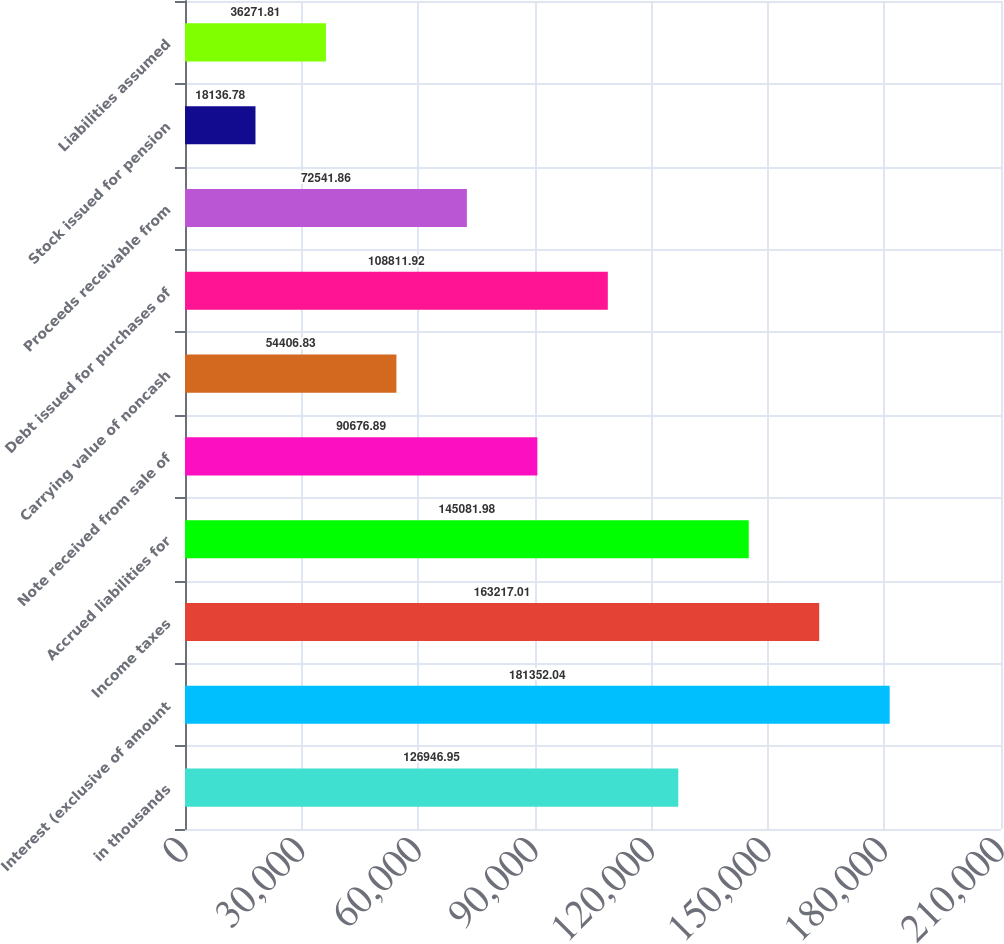Convert chart. <chart><loc_0><loc_0><loc_500><loc_500><bar_chart><fcel>in thousands<fcel>Interest (exclusive of amount<fcel>Income taxes<fcel>Accrued liabilities for<fcel>Note received from sale of<fcel>Carrying value of noncash<fcel>Debt issued for purchases of<fcel>Proceeds receivable from<fcel>Stock issued for pension<fcel>Liabilities assumed<nl><fcel>126947<fcel>181352<fcel>163217<fcel>145082<fcel>90676.9<fcel>54406.8<fcel>108812<fcel>72541.9<fcel>18136.8<fcel>36271.8<nl></chart> 